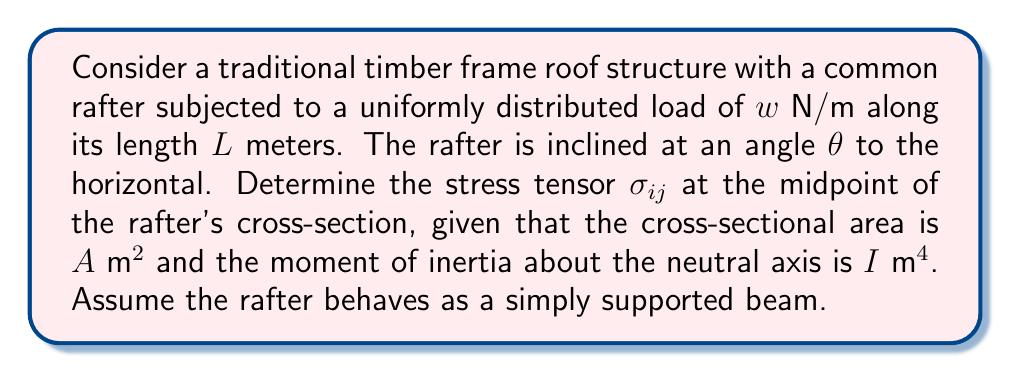Show me your answer to this math problem. To solve this problem, we'll follow these steps:

1) First, calculate the reactions at the supports:
   The vertical reaction at each support is $R = \frac{wL}{2}$

2) Calculate the bending moment $M$ at the midpoint:
   $$M = \frac{wL^2}{8}$$

3) Calculate the normal force $N$ along the rafter:
   $$N = \frac{wL}{2} \sin\theta$$

4) The stress tensor $\sigma_{ij}$ for a beam under combined bending and axial load is:

   $$\sigma_{ij} = \begin{pmatrix}
   \sigma_{xx} & \tau_{xy} & 0 \\
   \tau_{xy} & 0 & 0 \\
   0 & 0 & 0
   \end{pmatrix}$$

   Where:
   $$\sigma_{xx} = \frac{N}{A} \pm \frac{My}{I}$$
   $$\tau_{xy} = \frac{VQ}{Ib}$$

5) At the midpoint of the cross-section, $y = 0$, so:
   $$\sigma_{xx} = \frac{N}{A} = \frac{wL \sin\theta}{2A}$$

6) The shear force $V$ at the midpoint is zero, so $\tau_{xy} = 0$

Therefore, the stress tensor at the midpoint of the rafter's cross-section is:

$$\sigma_{ij} = \begin{pmatrix}
\frac{wL \sin\theta}{2A} & 0 & 0 \\
0 & 0 & 0 \\
0 & 0 & 0
\end{pmatrix}$$
Answer: $$\sigma_{ij} = \begin{pmatrix}
\frac{wL \sin\theta}{2A} & 0 & 0 \\
0 & 0 & 0 \\
0 & 0 & 0
\end{pmatrix}$$ 